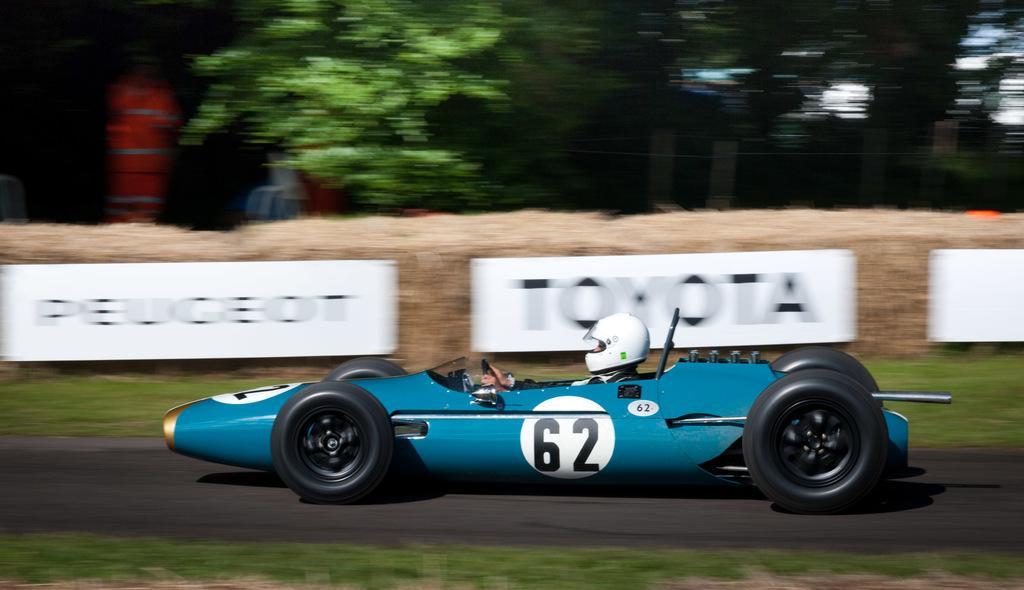How would you summarize this image in a sentence or two? In this image I can see a road in the front and on it I can see a blue colour vehicle. In this vehicle I can see a person is sitting and I can see this person is wearing white colour helmet. In the background I can see few white colour boards, number of trees and on these boards I can see something is written. On the top left side of this image I can see an orange colour thing. I can also see this image is little bit blurry in the background and on this vehicle I can see something is written. 